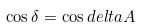<formula> <loc_0><loc_0><loc_500><loc_500>\cos \delta = \cos d e l t a A</formula> 